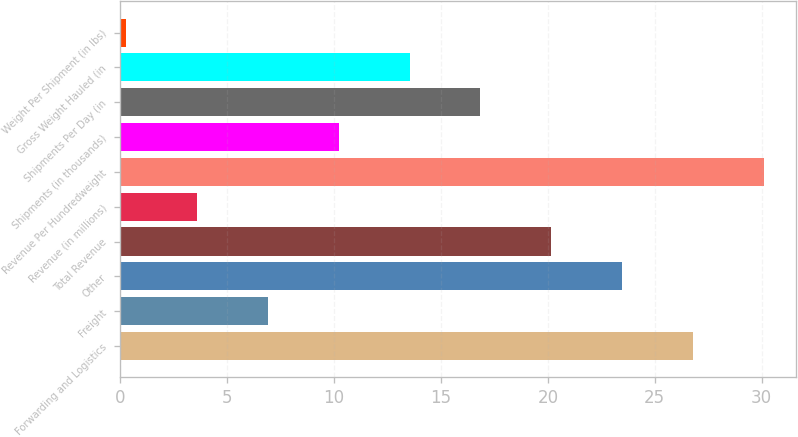Convert chart to OTSL. <chart><loc_0><loc_0><loc_500><loc_500><bar_chart><fcel>Forwarding and Logistics<fcel>Freight<fcel>Other<fcel>Total Revenue<fcel>Revenue (in millions)<fcel>Revenue Per Hundredweight<fcel>Shipments (in thousands)<fcel>Shipments Per Day (in<fcel>Gross Weight Hauled (in<fcel>Weight Per Shipment (in lbs)<nl><fcel>26.78<fcel>6.92<fcel>23.47<fcel>20.16<fcel>3.61<fcel>30.09<fcel>10.23<fcel>16.85<fcel>13.54<fcel>0.3<nl></chart> 